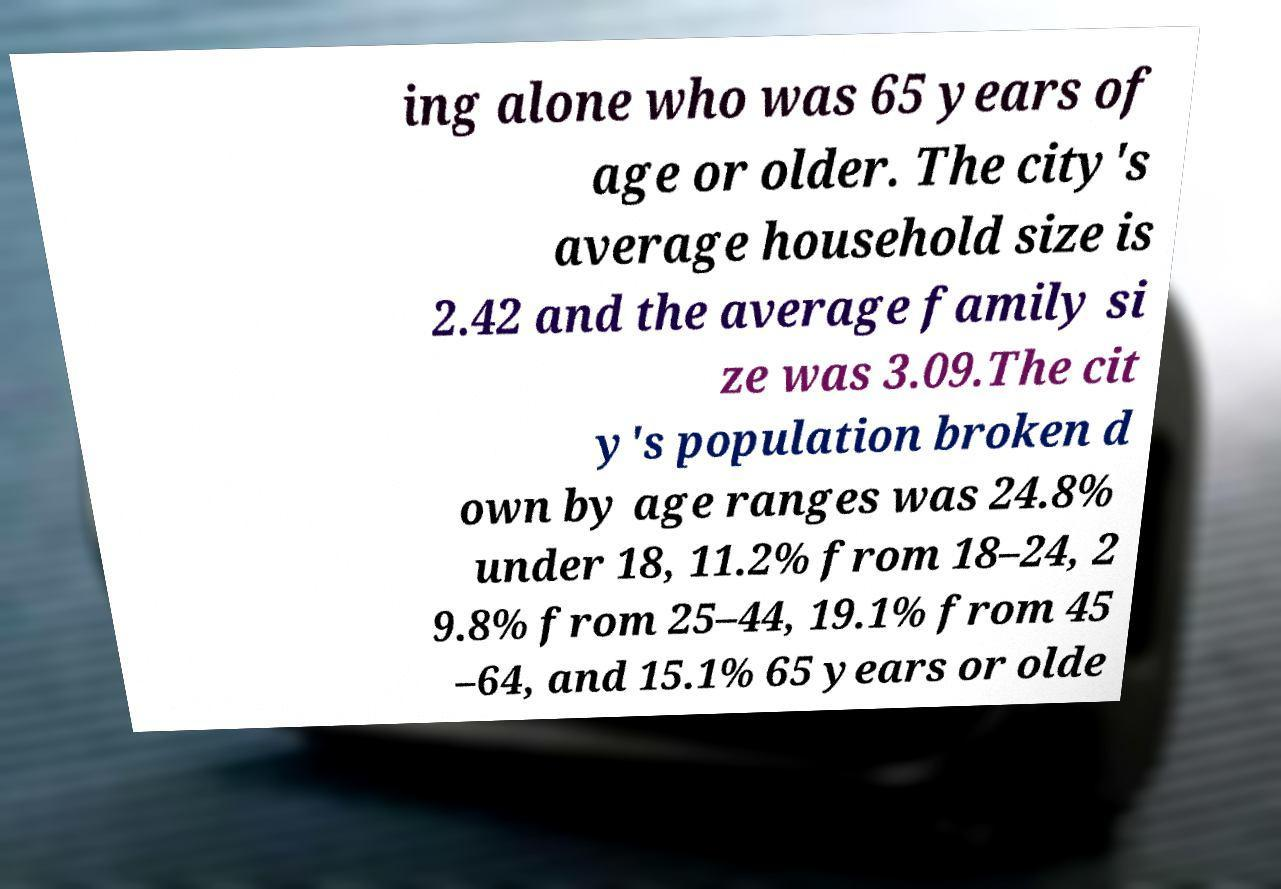Please read and relay the text visible in this image. What does it say? ing alone who was 65 years of age or older. The city's average household size is 2.42 and the average family si ze was 3.09.The cit y's population broken d own by age ranges was 24.8% under 18, 11.2% from 18–24, 2 9.8% from 25–44, 19.1% from 45 –64, and 15.1% 65 years or olde 